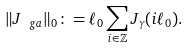Convert formula to latex. <formula><loc_0><loc_0><loc_500><loc_500>\| J _ { \ g a } \| _ { 0 } \colon = \ell _ { 0 } \sum _ { i \in \mathbb { Z } } J _ { \gamma } ( i \ell _ { 0 } ) .</formula> 